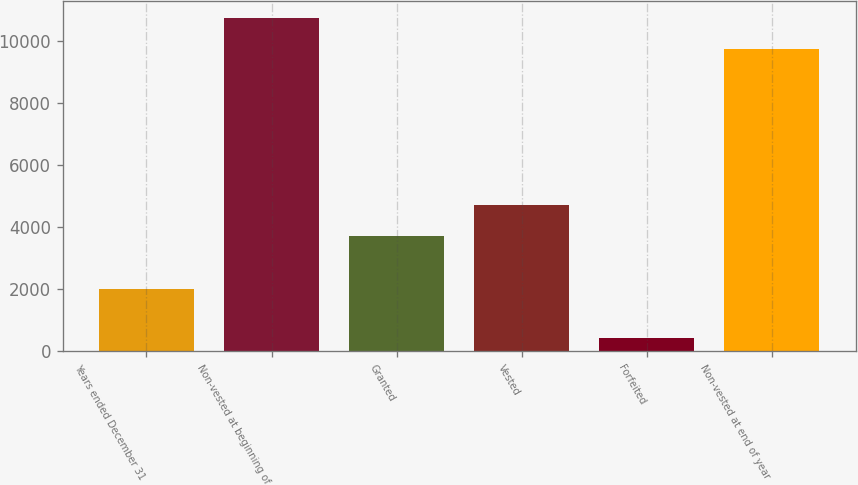Convert chart to OTSL. <chart><loc_0><loc_0><loc_500><loc_500><bar_chart><fcel>Years ended December 31<fcel>Non-vested at beginning of<fcel>Granted<fcel>Vested<fcel>Forfeited<fcel>Non-vested at end of year<nl><fcel>2013<fcel>10758<fcel>3714<fcel>4713<fcel>442<fcel>9759<nl></chart> 